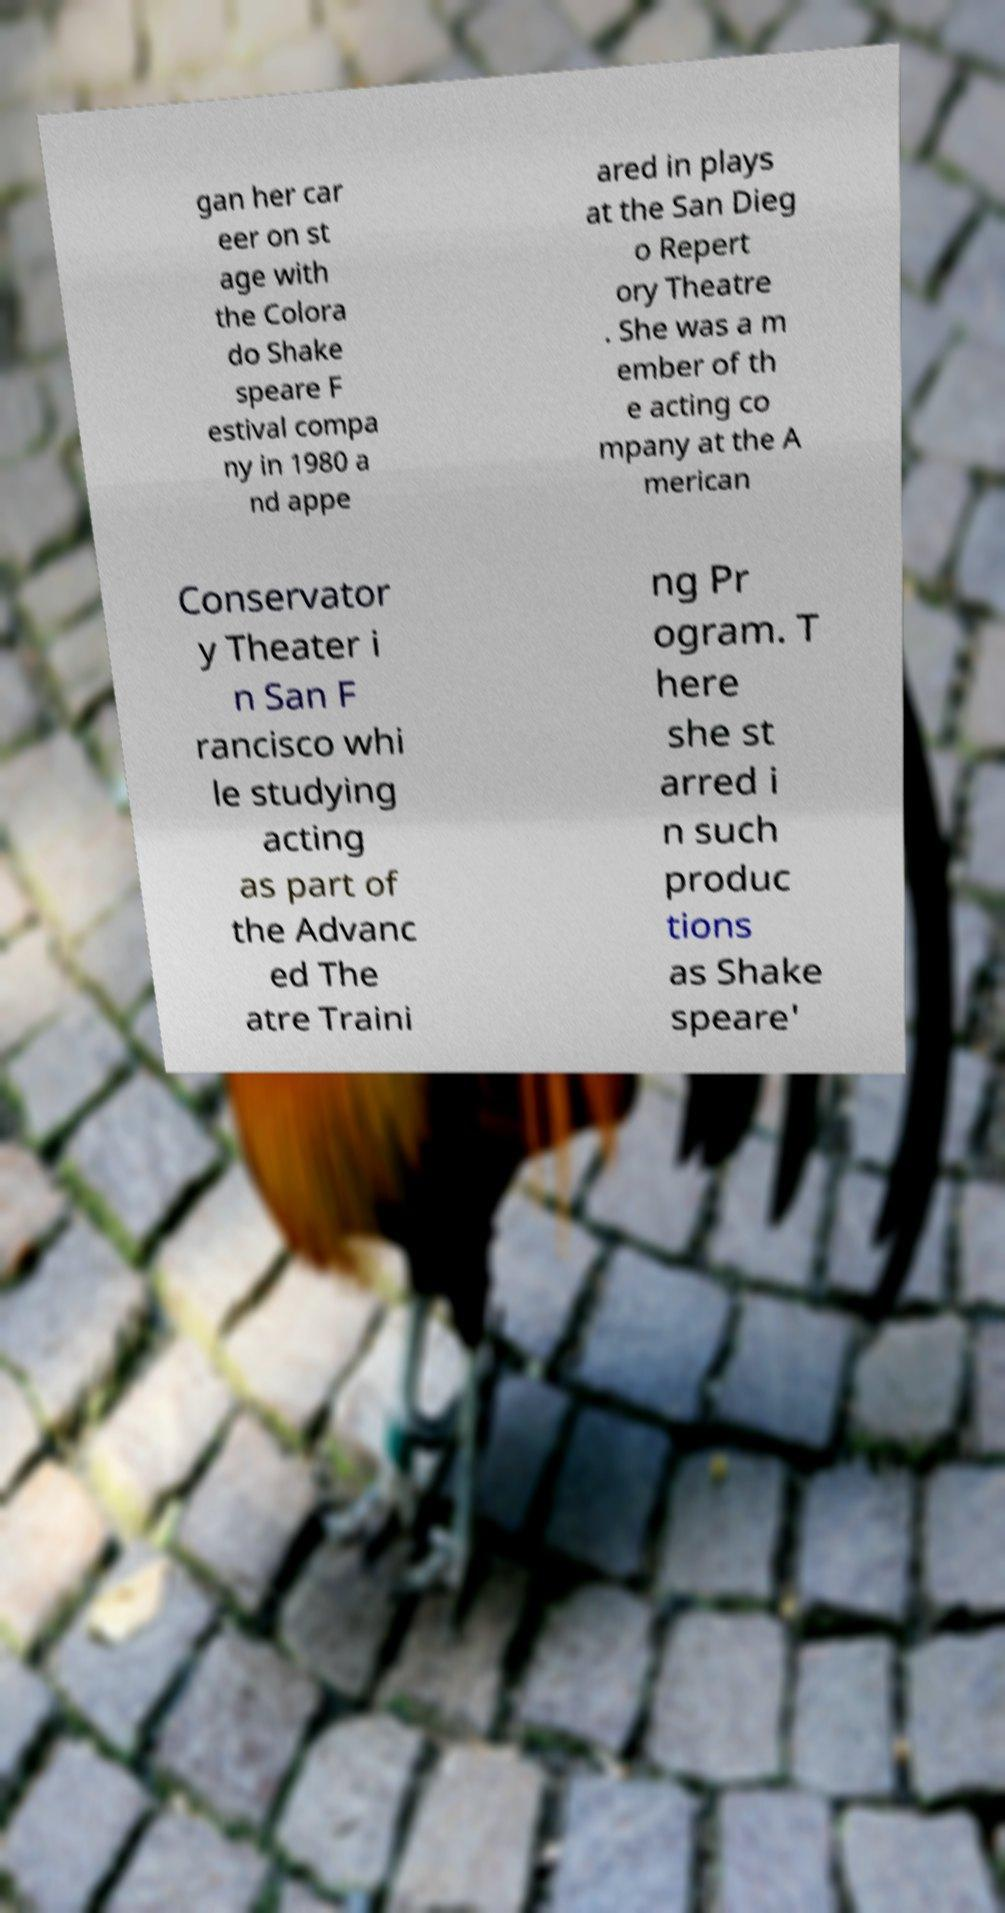Please identify and transcribe the text found in this image. gan her car eer on st age with the Colora do Shake speare F estival compa ny in 1980 a nd appe ared in plays at the San Dieg o Repert ory Theatre . She was a m ember of th e acting co mpany at the A merican Conservator y Theater i n San F rancisco whi le studying acting as part of the Advanc ed The atre Traini ng Pr ogram. T here she st arred i n such produc tions as Shake speare' 